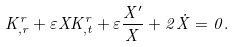<formula> <loc_0><loc_0><loc_500><loc_500>K ^ { r } _ { , r } + \varepsilon X K ^ { r } _ { , t } + \varepsilon \frac { X ^ { \prime } } { X } + 2 { \dot { X } } = 0 .</formula> 